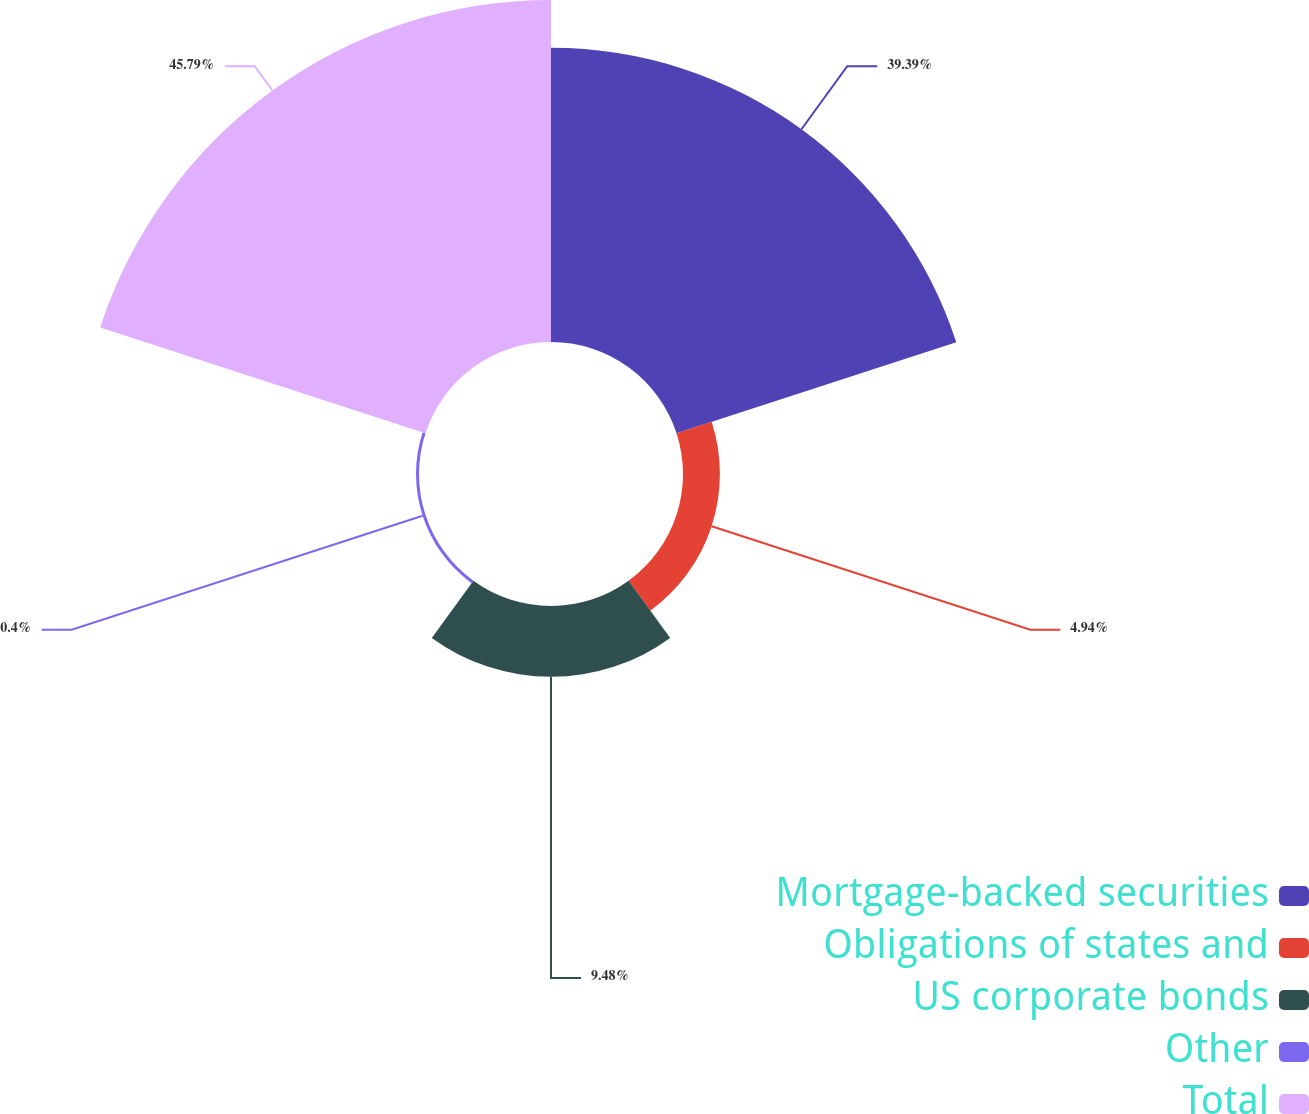Convert chart. <chart><loc_0><loc_0><loc_500><loc_500><pie_chart><fcel>Mortgage-backed securities<fcel>Obligations of states and<fcel>US corporate bonds<fcel>Other<fcel>Total<nl><fcel>39.39%<fcel>4.94%<fcel>9.48%<fcel>0.4%<fcel>45.8%<nl></chart> 